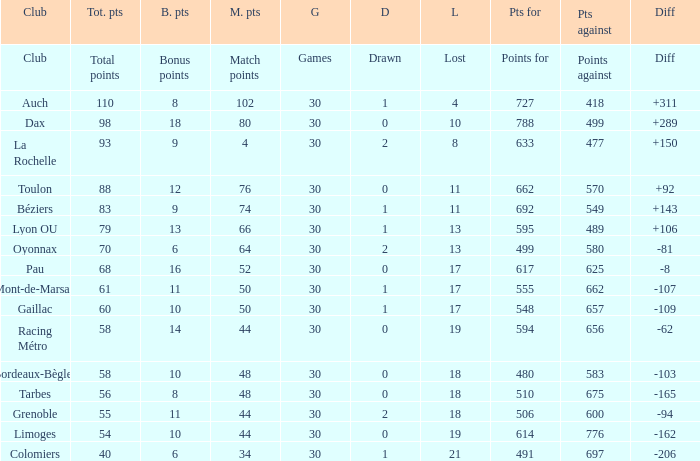What is the number of games for a club that has 34 match points? 30.0. 